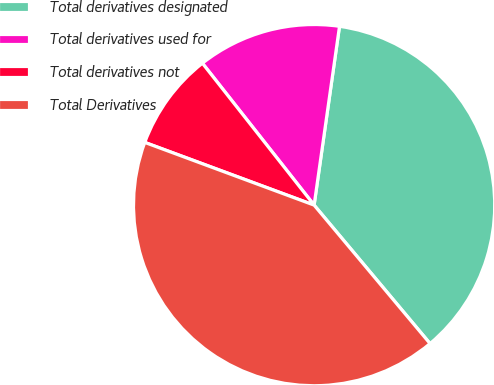Convert chart. <chart><loc_0><loc_0><loc_500><loc_500><pie_chart><fcel>Total derivatives designated<fcel>Total derivatives used for<fcel>Total derivatives not<fcel>Total Derivatives<nl><fcel>36.66%<fcel>12.86%<fcel>8.74%<fcel>41.74%<nl></chart> 